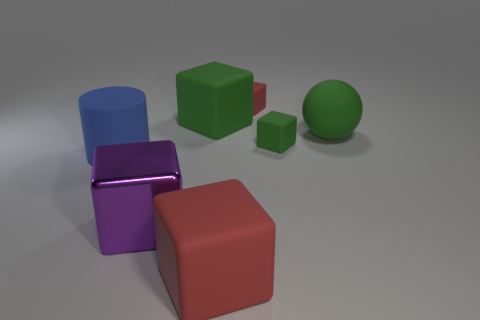How many red cubes must be subtracted to get 1 red cubes? 1 Add 1 green rubber objects. How many objects exist? 8 Subtract all rubber cubes. How many cubes are left? 1 Subtract all blocks. How many objects are left? 2 Subtract 1 cubes. How many cubes are left? 4 Add 2 tiny green rubber things. How many tiny green rubber things exist? 3 Subtract all red cubes. How many cubes are left? 3 Subtract 2 red cubes. How many objects are left? 5 Subtract all cyan balls. Subtract all red cylinders. How many balls are left? 1 Subtract all gray balls. How many red cylinders are left? 0 